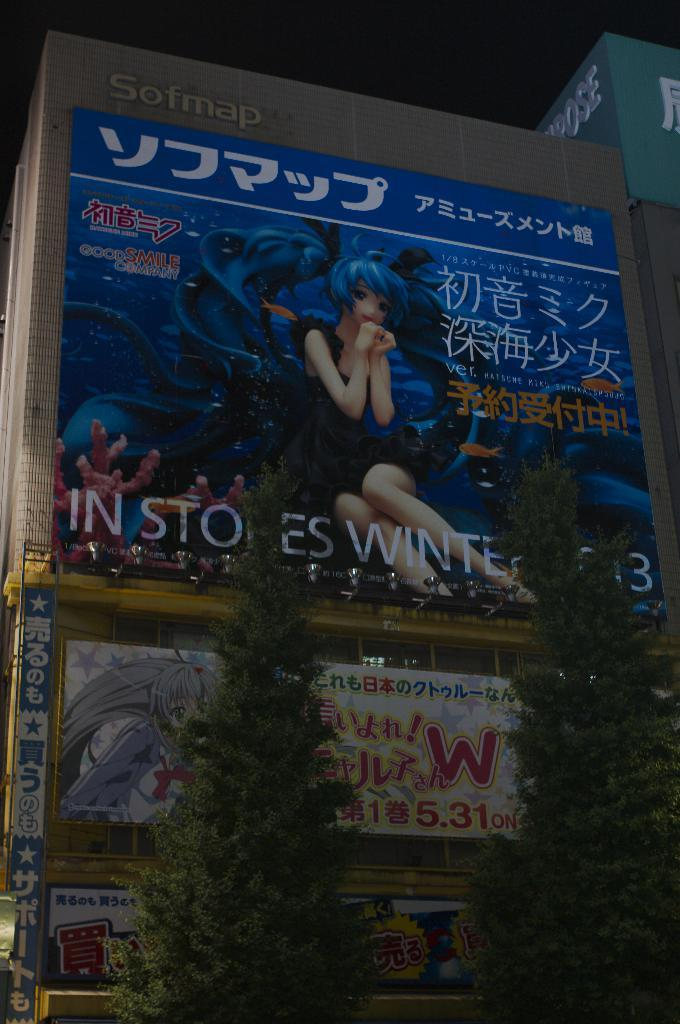<image>
Provide a brief description of the given image. A poster has the words In Stores Winter, but the R in both stores and winter is partially obscured by a bush. 